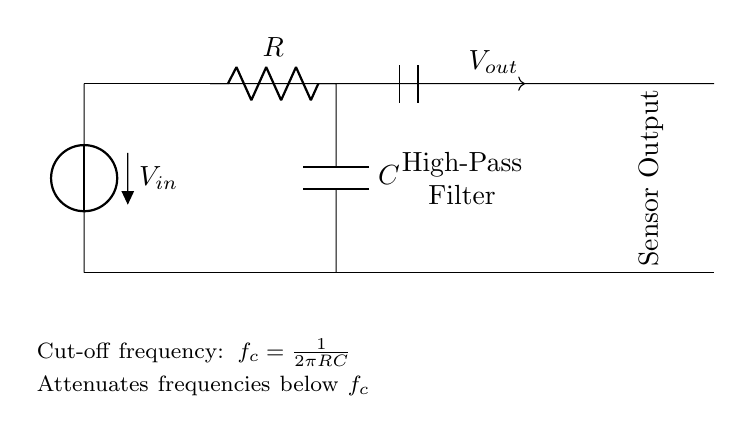What is the function of this circuit? The function of this circuit is to act as a high-pass filter, which allows high-frequency signals to pass while attenuating low-frequency signals.
Answer: High-pass filter What are the main components used in this circuit? The main components in the circuit are a resistor and a capacitor, which work together to filter the input signal.
Answer: Resistor and capacitor What is the cut-off frequency formula for this filter? The cut-off frequency formula is given by the equation \(f_c = \frac{1}{2\pi RC}\), where R is the resistance and C is the capacitance.
Answer: f_c = 1/(2πRC) What is the output voltage source in this circuit? The output voltage source indicated in the circuit is labeled as V_out, which represents the voltage across the output of the filter.
Answer: V_out Which frequencies does this circuit attenuate? This circuit attenuates frequencies below the cut-off frequency, allowing higher frequencies to pass through without significant loss.
Answer: Frequencies below the cut-off frequency Why is there a voltage source V_in in the diagram? The voltage source V_in provides the input signal to the high-pass filter, which is then processed to eliminate low-frequency vibrations.
Answer: Input signal What type of signal would be ideal for this filter to process? The ideal signal for this high-pass filter to process would be one containing primarily high-frequency components, such as vibrations from machinery operation.
Answer: High-frequency signal 